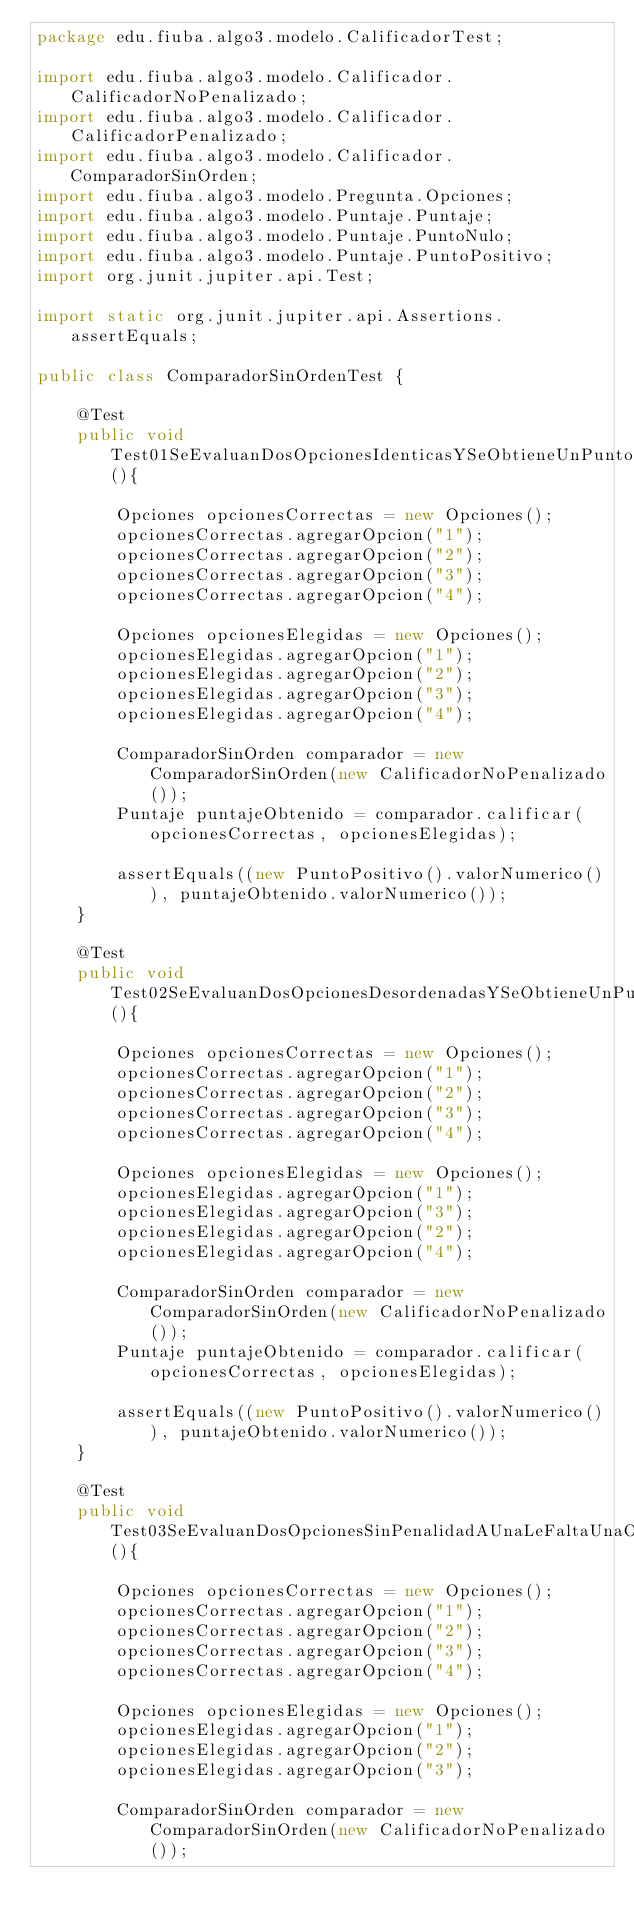Convert code to text. <code><loc_0><loc_0><loc_500><loc_500><_Java_>package edu.fiuba.algo3.modelo.CalificadorTest;

import edu.fiuba.algo3.modelo.Calificador.CalificadorNoPenalizado;
import edu.fiuba.algo3.modelo.Calificador.CalificadorPenalizado;
import edu.fiuba.algo3.modelo.Calificador.ComparadorSinOrden;
import edu.fiuba.algo3.modelo.Pregunta.Opciones;
import edu.fiuba.algo3.modelo.Puntaje.Puntaje;
import edu.fiuba.algo3.modelo.Puntaje.PuntoNulo;
import edu.fiuba.algo3.modelo.Puntaje.PuntoPositivo;
import org.junit.jupiter.api.Test;

import static org.junit.jupiter.api.Assertions.assertEquals;

public class ComparadorSinOrdenTest {

    @Test
    public void Test01SeEvaluanDosOpcionesIdenticasYSeObtieneUnPuntoPositivo(){

        Opciones opcionesCorrectas = new Opciones();
        opcionesCorrectas.agregarOpcion("1");
        opcionesCorrectas.agregarOpcion("2");
        opcionesCorrectas.agregarOpcion("3");
        opcionesCorrectas.agregarOpcion("4");

        Opciones opcionesElegidas = new Opciones();
        opcionesElegidas.agregarOpcion("1");
        opcionesElegidas.agregarOpcion("2");
        opcionesElegidas.agregarOpcion("3");
        opcionesElegidas.agregarOpcion("4");

        ComparadorSinOrden comparador = new ComparadorSinOrden(new CalificadorNoPenalizado());
        Puntaje puntajeObtenido = comparador.calificar(opcionesCorrectas, opcionesElegidas);

        assertEquals((new PuntoPositivo().valorNumerico()), puntajeObtenido.valorNumerico());
    }

    @Test
    public void Test02SeEvaluanDosOpcionesDesordenadasYSeObtieneUnPuntoPositivo(){

        Opciones opcionesCorrectas = new Opciones();
        opcionesCorrectas.agregarOpcion("1");
        opcionesCorrectas.agregarOpcion("2");
        opcionesCorrectas.agregarOpcion("3");
        opcionesCorrectas.agregarOpcion("4");

        Opciones opcionesElegidas = new Opciones();
        opcionesElegidas.agregarOpcion("1");
        opcionesElegidas.agregarOpcion("3");
        opcionesElegidas.agregarOpcion("2");
        opcionesElegidas.agregarOpcion("4");

        ComparadorSinOrden comparador = new ComparadorSinOrden(new CalificadorNoPenalizado());
        Puntaje puntajeObtenido = comparador.calificar(opcionesCorrectas, opcionesElegidas);

        assertEquals((new PuntoPositivo().valorNumerico()), puntajeObtenido.valorNumerico());
    }

    @Test
    public void Test03SeEvaluanDosOpcionesSinPenalidadAUnaLeFaltaUnaOpcionSeDevuelveUnPuntoNulo(){

        Opciones opcionesCorrectas = new Opciones();
        opcionesCorrectas.agregarOpcion("1");
        opcionesCorrectas.agregarOpcion("2");
        opcionesCorrectas.agregarOpcion("3");
        opcionesCorrectas.agregarOpcion("4");

        Opciones opcionesElegidas = new Opciones();
        opcionesElegidas.agregarOpcion("1");
        opcionesElegidas.agregarOpcion("2");
        opcionesElegidas.agregarOpcion("3");

        ComparadorSinOrden comparador = new ComparadorSinOrden(new CalificadorNoPenalizado());</code> 